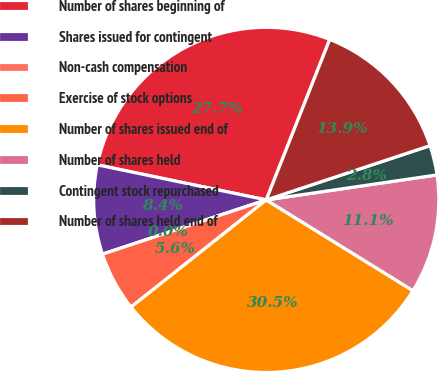Convert chart. <chart><loc_0><loc_0><loc_500><loc_500><pie_chart><fcel>Number of shares beginning of<fcel>Shares issued for contingent<fcel>Non-cash compensation<fcel>Exercise of stock options<fcel>Number of shares issued end of<fcel>Number of shares held<fcel>Contingent stock repurchased<fcel>Number of shares held end of<nl><fcel>27.74%<fcel>8.35%<fcel>0.0%<fcel>5.57%<fcel>30.52%<fcel>11.13%<fcel>2.78%<fcel>13.91%<nl></chart> 